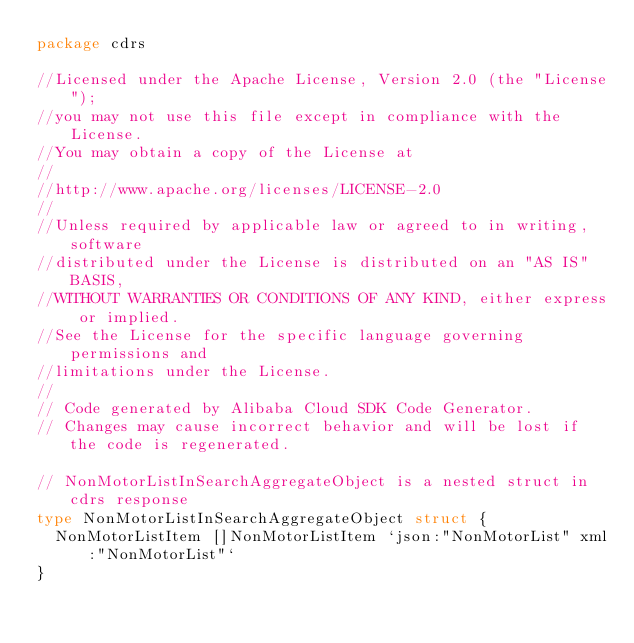<code> <loc_0><loc_0><loc_500><loc_500><_Go_>package cdrs

//Licensed under the Apache License, Version 2.0 (the "License");
//you may not use this file except in compliance with the License.
//You may obtain a copy of the License at
//
//http://www.apache.org/licenses/LICENSE-2.0
//
//Unless required by applicable law or agreed to in writing, software
//distributed under the License is distributed on an "AS IS" BASIS,
//WITHOUT WARRANTIES OR CONDITIONS OF ANY KIND, either express or implied.
//See the License for the specific language governing permissions and
//limitations under the License.
//
// Code generated by Alibaba Cloud SDK Code Generator.
// Changes may cause incorrect behavior and will be lost if the code is regenerated.

// NonMotorListInSearchAggregateObject is a nested struct in cdrs response
type NonMotorListInSearchAggregateObject struct {
	NonMotorListItem []NonMotorListItem `json:"NonMotorList" xml:"NonMotorList"`
}
</code> 